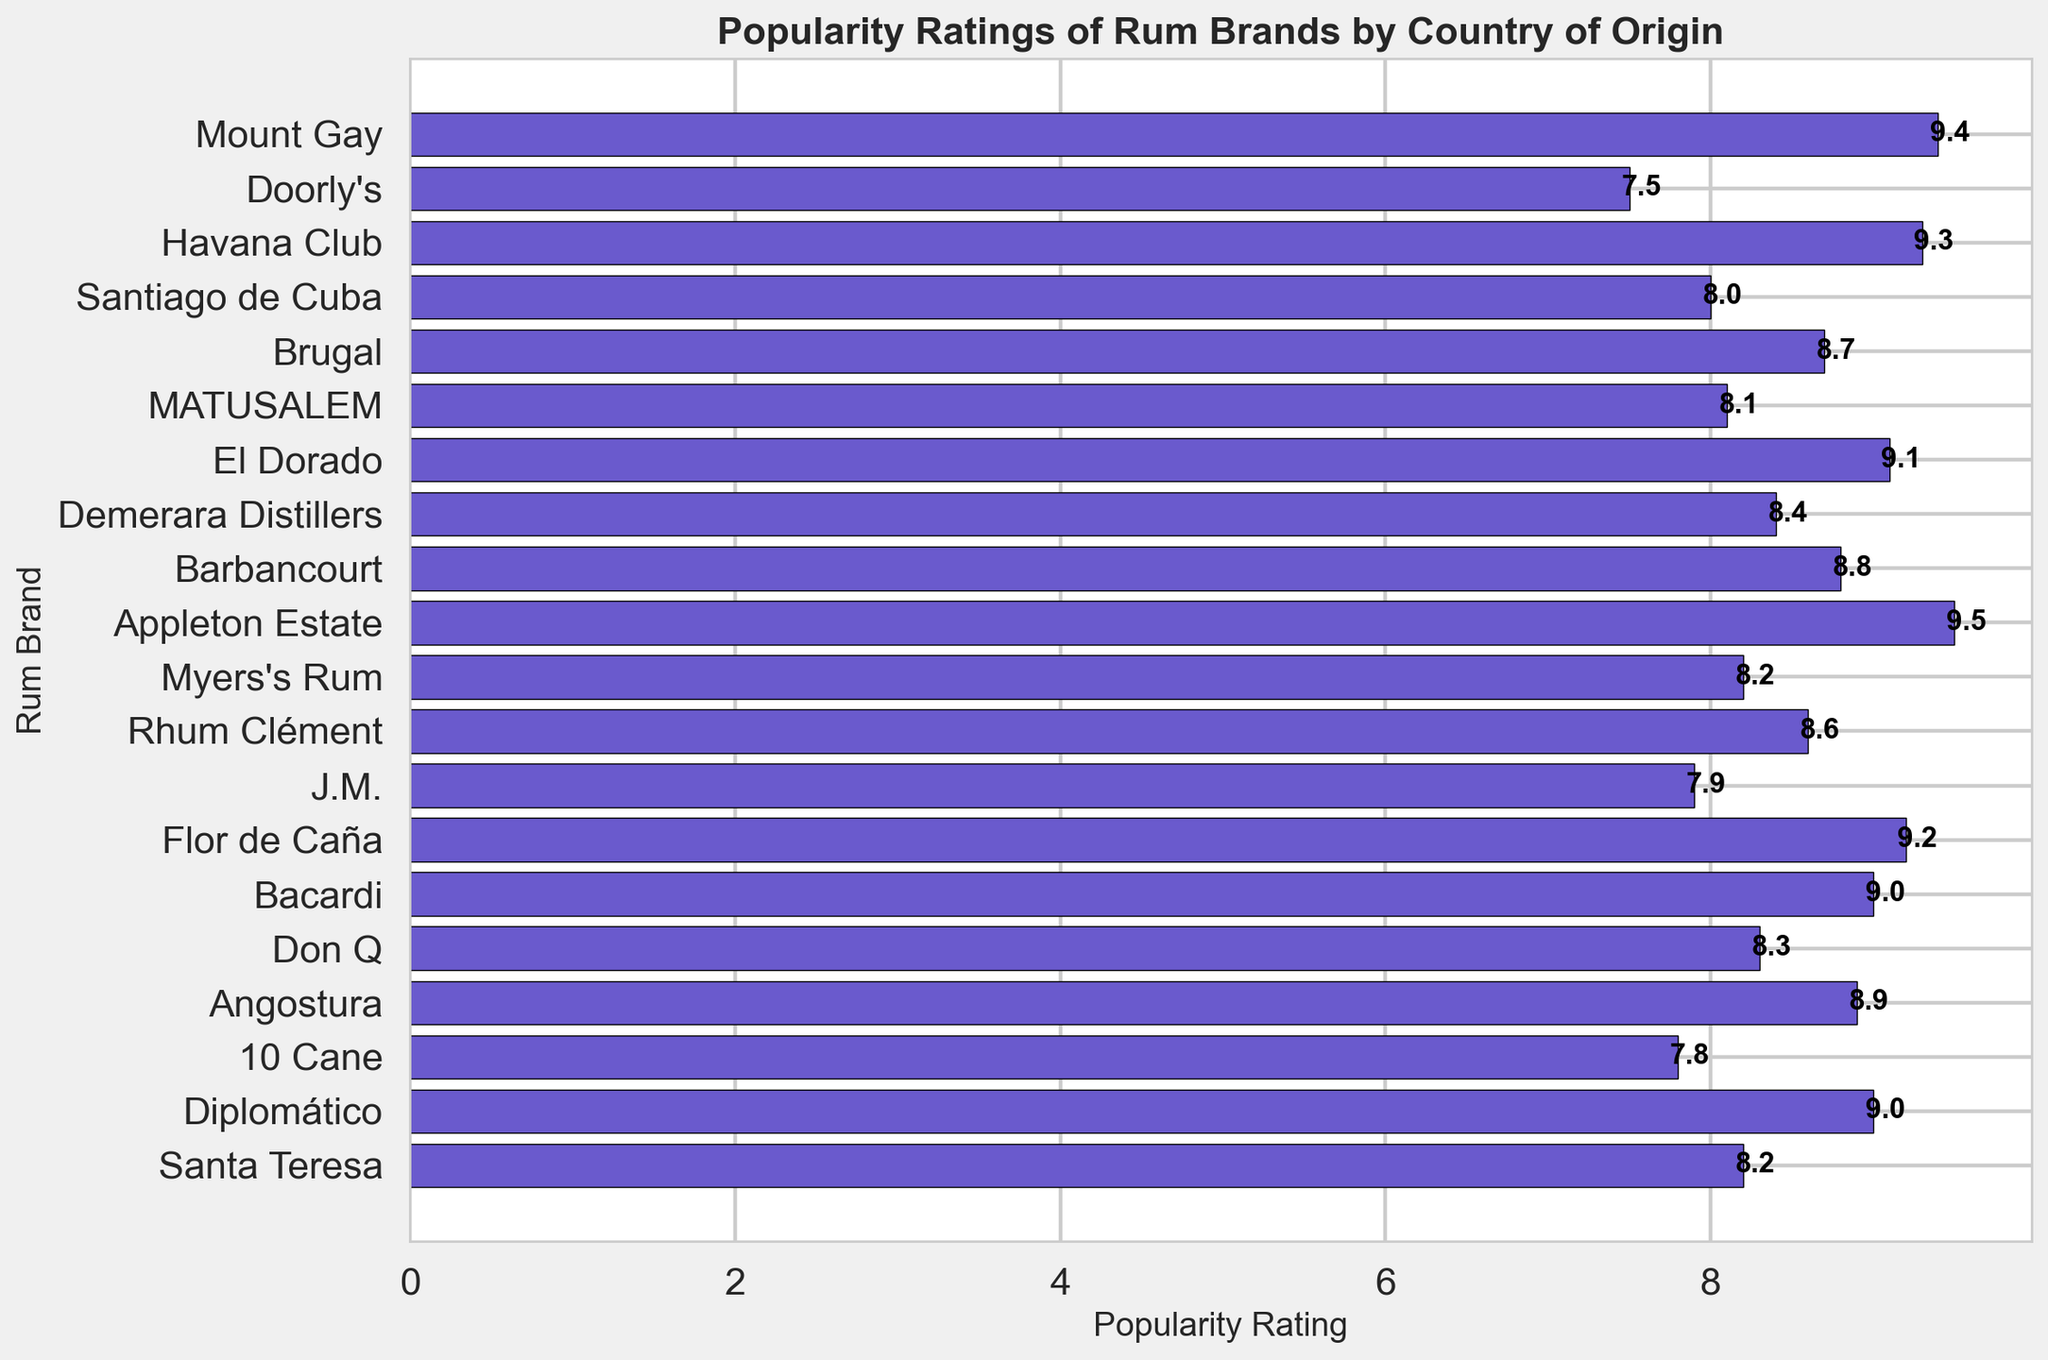Which rum brand has the highest popularity rating? The highest popularity rating can be observed by looking at the topmost bar in the inverted bar chart.
Answer: Appleton Estate Which rum brand has the lowest popularity rating? The lowest popularity rating can be observed by looking at the bottom bar in the inverted bar chart.
Answer: Doorly's What is the difference in popularity rating between the highest-rated and lowest-rated rum brands? The highest rating is 9.5 (Appleton Estate) and the lowest rating is 7.5 (Doorly's). The difference is calculated as 9.5 - 7.5.
Answer: 2.0 Which country has the most rum brands listed in this chart? By counting the number of bars associated with each country, we can see that Jamaica, Cuba, Puerto Rico, Barbados, Trinidad & Tobago all have multiple brands, but no country has more than two brands listed.
Answer: Multiple countries (Jamaica, Cuba, Puerto Rico, Barbados, Trinidad & Tobago) What is the average popularity rating of rum brands from Cuba? The rum brands from Cuba are Havana Club (9.3) and Santiago de Cuba (8.0). The average is calculated as (9.3 + 8.0) / 2.
Answer: 8.65 How do the popularity ratings of rum brands from Venezuela compare to those from Martinique? The rum brands from Venezuela are Diplomático (9.0) and Santa Teresa (8.2), and those from Martinique are Rhum Clément (8.6) and J.M. (7.9). To compare, we look at the individual ratings for each group.
Answer: Venezuela: 9.0, 8.2; Martinique: 8.6, 7.9 What is the median popularity rating of all the rum brands listed? First, list all popularity ratings in ascending order: 7.5, 7.8, 7.9, 8.0, 8.1, 8.2, 8.2, 8.3, 8.4, 8.6, 8.7, 8.8, 8.9, 9.0, 9.0, 9.1, 9.2, 9.3, 9.4, 9.5. The median value is the middle value, which, in a list of 20 items, is the average of the 10th and 11th values: (8.6 + 8.7) / 2.
Answer: 8.65 Which brand from Trinidad & Tobago has a higher popularity rating? Looking at the bars for Trinidad & Tobago, Angostura (8.9) is higher than 10 Cane (7.8).
Answer: Angostura What is the combined popularity rating of all rum brands from Puerto Rico? The rum brands from Puerto Rico are Bacardi (9.0) and Don Q (8.3). The combined rating is calculated as 9.0 + 8.3.
Answer: 17.3 Are there any brands with the same popularity rating? If so, which ones? By examining the length of the bars, we can see that Diplomático (from Venezuela) and Bacardi (from Puerto Rico) both have a popularity rating of 9.0.
Answer: Diplomático and Bacardi 